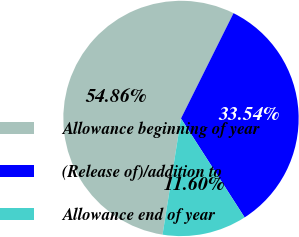<chart> <loc_0><loc_0><loc_500><loc_500><pie_chart><fcel>Allowance beginning of year<fcel>(Release of)/addition to<fcel>Allowance end of year<nl><fcel>54.86%<fcel>33.54%<fcel>11.6%<nl></chart> 